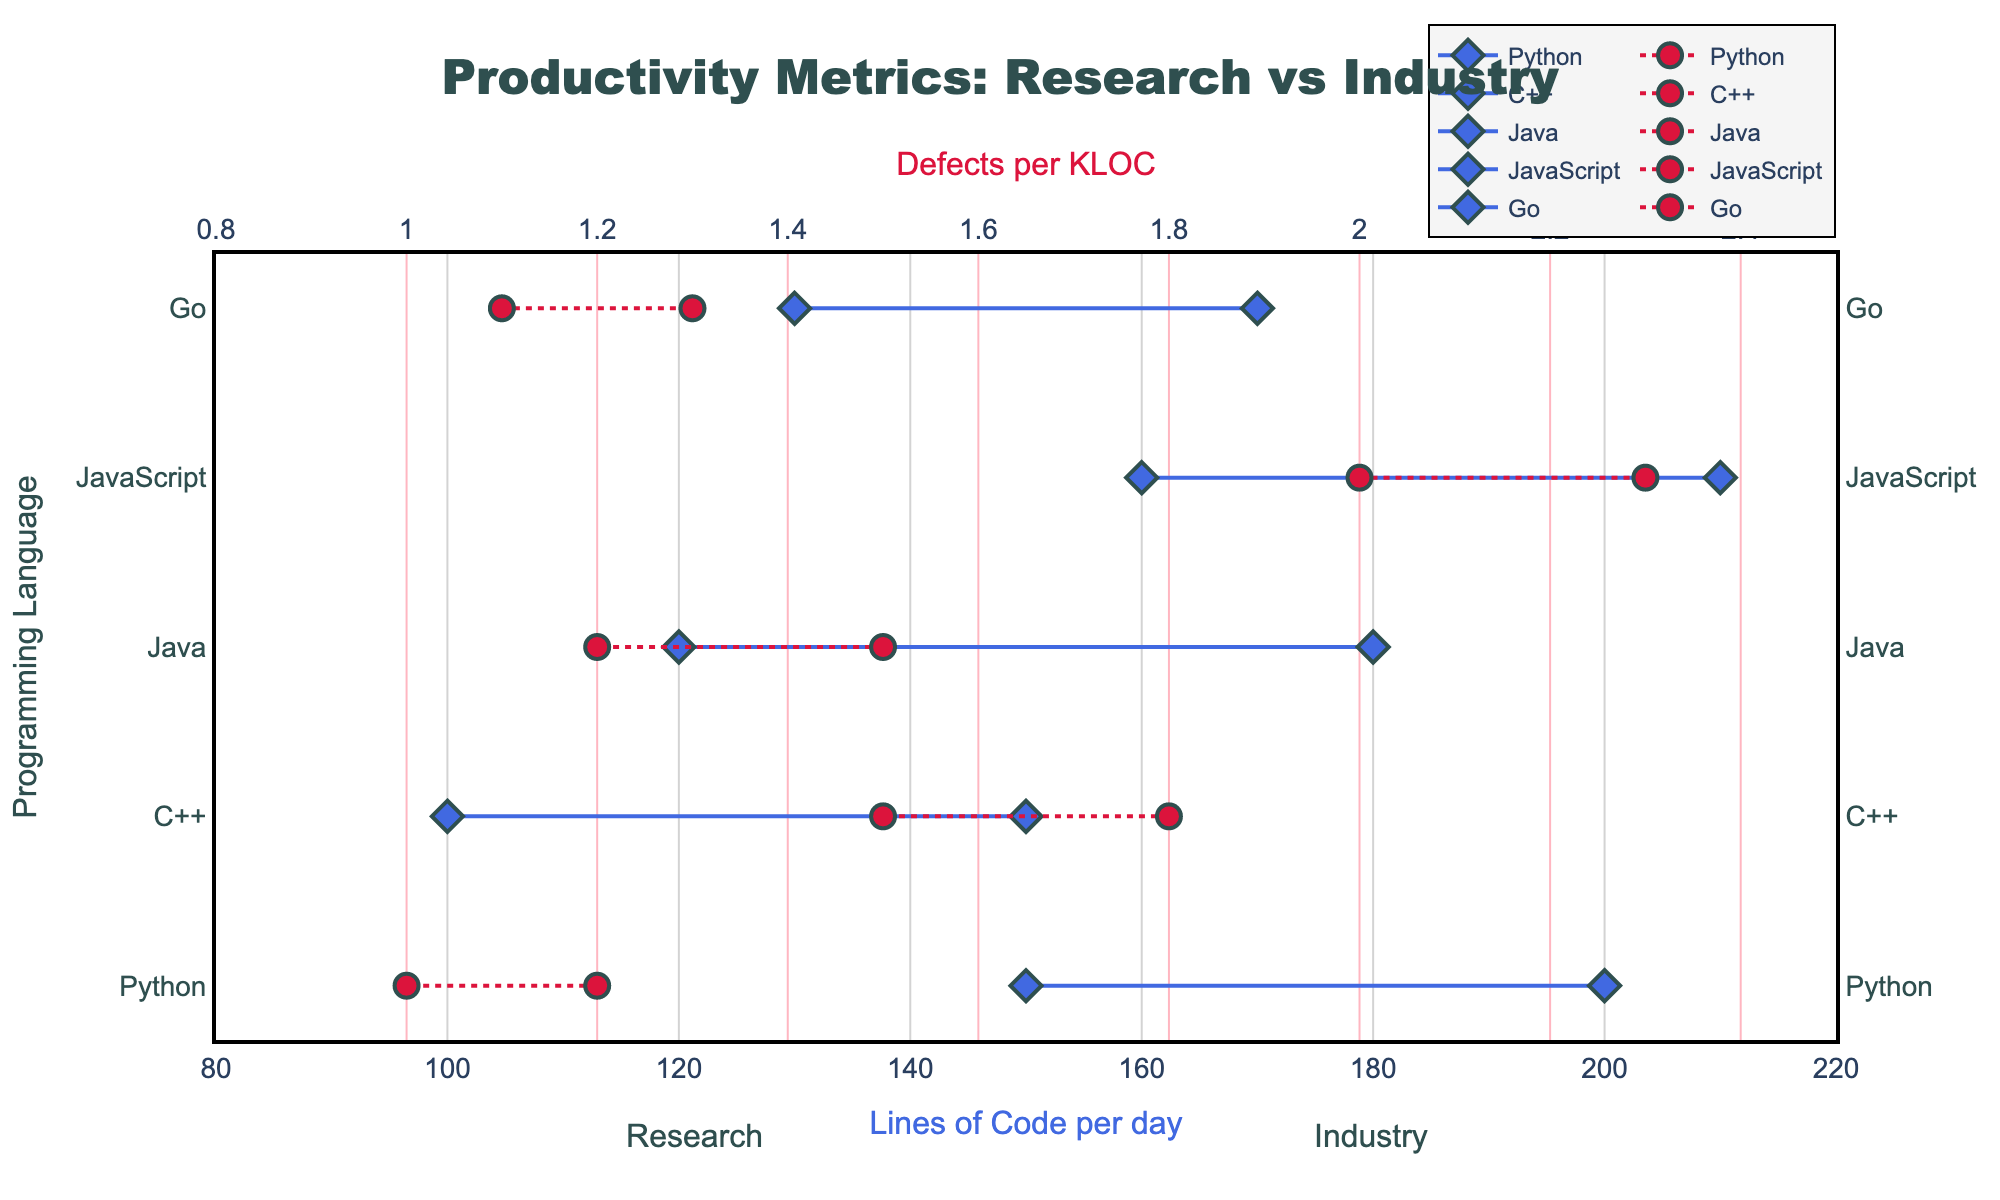What is the title of the figure? The title is located at the top of the figure. It is written in large, bold text.
Answer: Productivity Metrics: Research vs Industry How many programming languages are compared in the figure? Each horizontal line represents a different programming language. Count the lines from top to bottom.
Answer: 5 What color represents the markers and lines for "Lines of Code per day"? The markers for "Lines of Code per day" are diamonds, and the lines are colored in RoyalBlue. This can be seen from the legend or the visual characteristics of the plot.
Answer: RoyalBlue Which language has the highest "Lines of Code per day" in Industry? Check the position of the rightmost diamond markers across all lines. The rightmost diamond marks the highest value.
Answer: JavaScript Which language shows a decrease in "Defects per KLOC" from Research to Industry? Look for the circular markers connected by lines that show a downward slope from the Research side (left) to the Industry side (right) and check the colors matching Defects per KLOC.
Answer: Python What is the difference between the "Lines of Code per day" in Research and Industry for Java? Find the difference between the two diamond markers for Java's "Lines of Code per day." Industry value is 180, and Research value is 120. Subtract the smaller value from the larger one.
Answer: 60 Which language has the smallest gap between Research and Industry in "Defects per KLOC"? Measure the vertical distance between the circular markers for each language and compare them. The smallest gap indicates the smallest difference.
Answer: Python What is the average "Defects per KLOC" in Industry for all languages? Sum the "Defects per KLOC" in Industry values for all languages (1.0 + 1.5 + 1.2 + 2.3 + 1.3) and divide by the number of languages (5).
Answer: 1.46 How do Python and JavaScript compare in "Defects per KLOC" for Industry? Compare the Industry markers (circular) for Python and JavaScript on the x-axis representing "Defects per KLOC".
Answer: Python has fewer defects For which metric does C++ show a higher increase from Research to Industry? Compare the changes in both "Lines of Code per day" (100 to 150) and "Defects per KLOC" (1.8 to 1.5). The "Lines of Code per day" has a more significant increase.
Answer: Lines of Code per day 